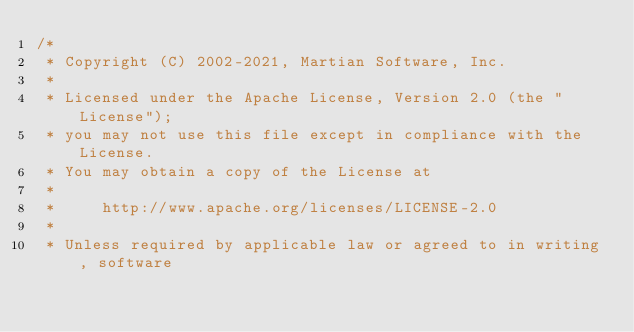<code> <loc_0><loc_0><loc_500><loc_500><_Java_>/*
 * Copyright (C) 2002-2021, Martian Software, Inc.
 *
 * Licensed under the Apache License, Version 2.0 (the "License");
 * you may not use this file except in compliance with the License.
 * You may obtain a copy of the License at
 *
 *     http://www.apache.org/licenses/LICENSE-2.0
 *
 * Unless required by applicable law or agreed to in writing, software</code> 